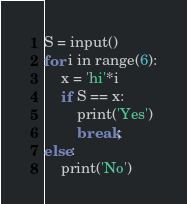<code> <loc_0><loc_0><loc_500><loc_500><_Python_>S = input()
for i in range(6):
    x = 'hi'*i
    if S == x:
        print('Yes')
        break;
else:
    print('No')
</code> 